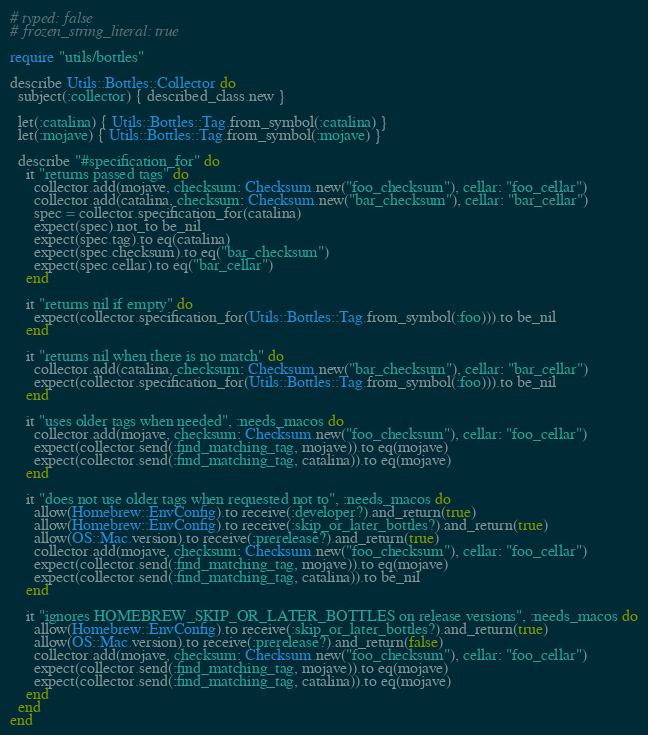Convert code to text. <code><loc_0><loc_0><loc_500><loc_500><_Ruby_># typed: false
# frozen_string_literal: true

require "utils/bottles"

describe Utils::Bottles::Collector do
  subject(:collector) { described_class.new }

  let(:catalina) { Utils::Bottles::Tag.from_symbol(:catalina) }
  let(:mojave) { Utils::Bottles::Tag.from_symbol(:mojave) }

  describe "#specification_for" do
    it "returns passed tags" do
      collector.add(mojave, checksum: Checksum.new("foo_checksum"), cellar: "foo_cellar")
      collector.add(catalina, checksum: Checksum.new("bar_checksum"), cellar: "bar_cellar")
      spec = collector.specification_for(catalina)
      expect(spec).not_to be_nil
      expect(spec.tag).to eq(catalina)
      expect(spec.checksum).to eq("bar_checksum")
      expect(spec.cellar).to eq("bar_cellar")
    end

    it "returns nil if empty" do
      expect(collector.specification_for(Utils::Bottles::Tag.from_symbol(:foo))).to be_nil
    end

    it "returns nil when there is no match" do
      collector.add(catalina, checksum: Checksum.new("bar_checksum"), cellar: "bar_cellar")
      expect(collector.specification_for(Utils::Bottles::Tag.from_symbol(:foo))).to be_nil
    end

    it "uses older tags when needed", :needs_macos do
      collector.add(mojave, checksum: Checksum.new("foo_checksum"), cellar: "foo_cellar")
      expect(collector.send(:find_matching_tag, mojave)).to eq(mojave)
      expect(collector.send(:find_matching_tag, catalina)).to eq(mojave)
    end

    it "does not use older tags when requested not to", :needs_macos do
      allow(Homebrew::EnvConfig).to receive(:developer?).and_return(true)
      allow(Homebrew::EnvConfig).to receive(:skip_or_later_bottles?).and_return(true)
      allow(OS::Mac.version).to receive(:prerelease?).and_return(true)
      collector.add(mojave, checksum: Checksum.new("foo_checksum"), cellar: "foo_cellar")
      expect(collector.send(:find_matching_tag, mojave)).to eq(mojave)
      expect(collector.send(:find_matching_tag, catalina)).to be_nil
    end

    it "ignores HOMEBREW_SKIP_OR_LATER_BOTTLES on release versions", :needs_macos do
      allow(Homebrew::EnvConfig).to receive(:skip_or_later_bottles?).and_return(true)
      allow(OS::Mac.version).to receive(:prerelease?).and_return(false)
      collector.add(mojave, checksum: Checksum.new("foo_checksum"), cellar: "foo_cellar")
      expect(collector.send(:find_matching_tag, mojave)).to eq(mojave)
      expect(collector.send(:find_matching_tag, catalina)).to eq(mojave)
    end
  end
end
</code> 